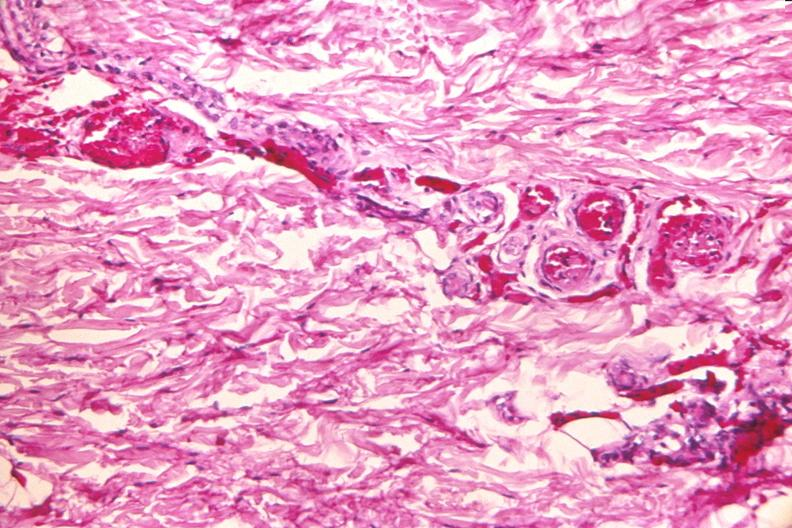does metastatic neuroblastoma show skin, petechial hemorrhages from patient with meningococcemia?
Answer the question using a single word or phrase. No 